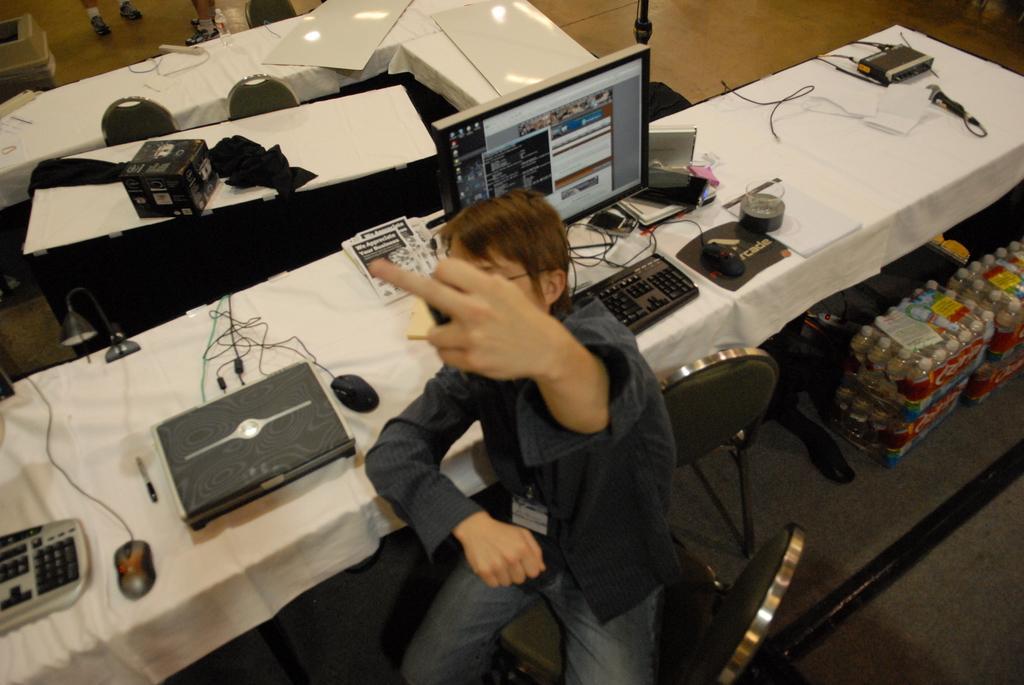How would you summarize this image in a sentence or two? In this image we can see a person sitting on the chair, desktops, mouse pads, cables, books, pens, cardboard cartons and disposal bottles packed in the covers. 